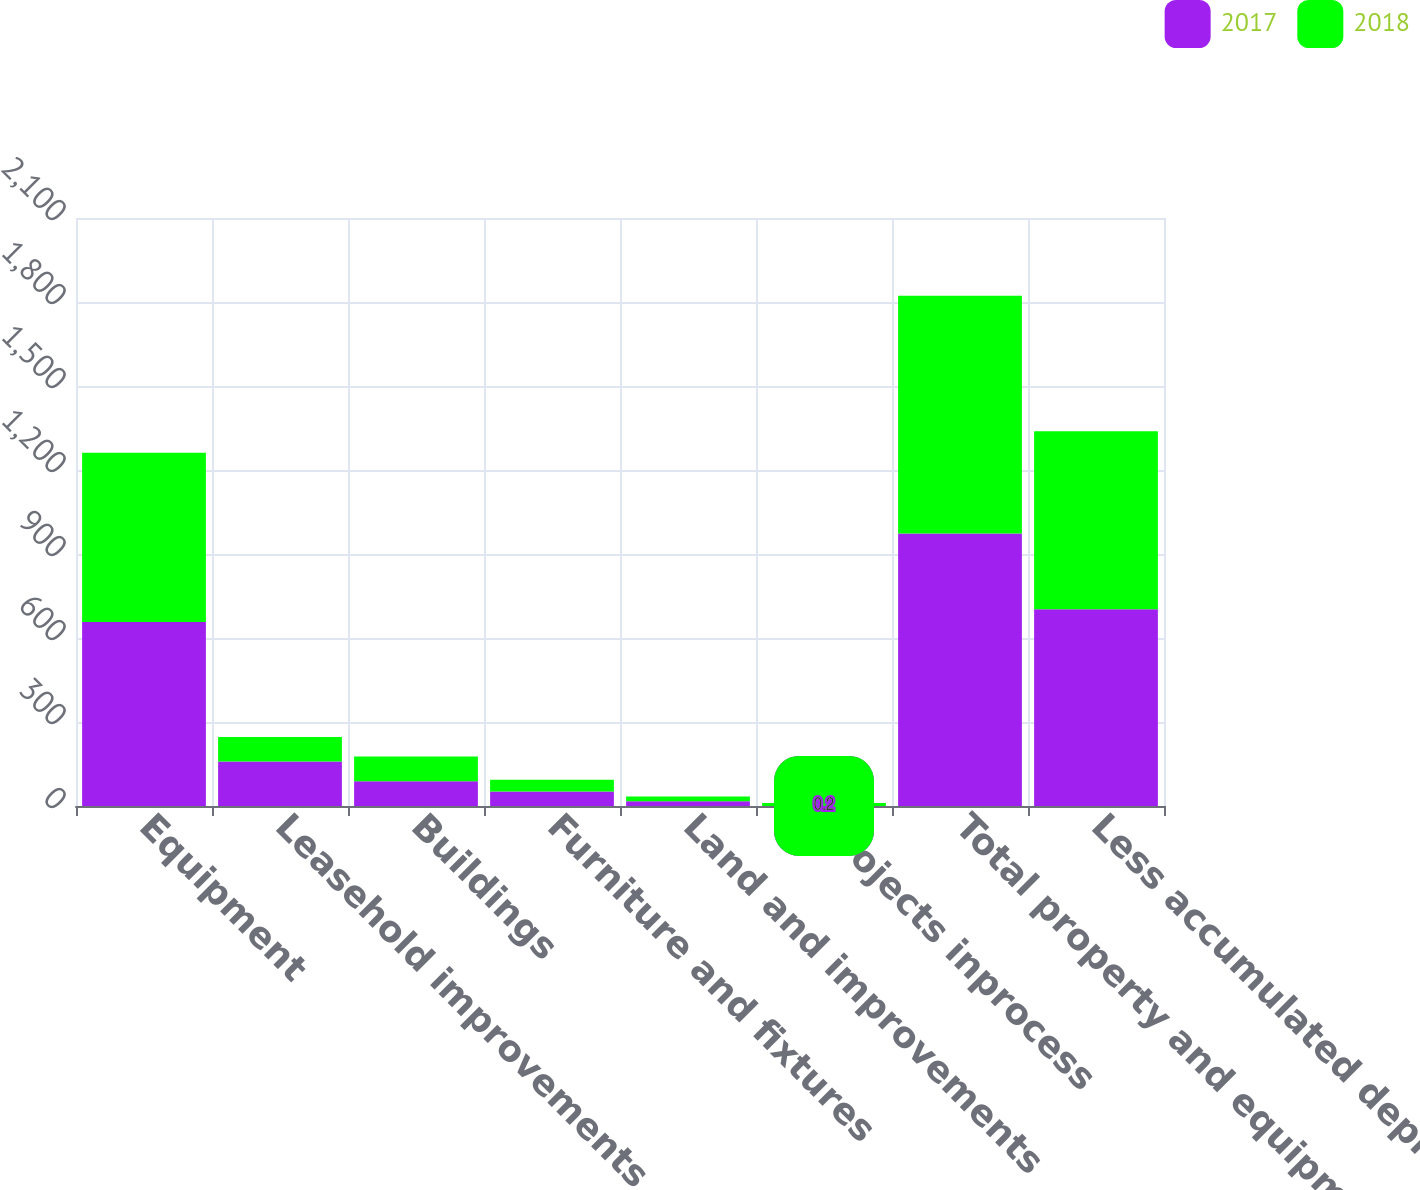Convert chart to OTSL. <chart><loc_0><loc_0><loc_500><loc_500><stacked_bar_chart><ecel><fcel>Equipment<fcel>Leasehold improvements<fcel>Buildings<fcel>Furniture and fixtures<fcel>Land and improvements<fcel>Projects inprocess<fcel>Total property and equipment<fcel>Less accumulated depreciation<nl><fcel>2017<fcel>656.8<fcel>158.6<fcel>88.6<fcel>51.6<fcel>17<fcel>0.2<fcel>972.8<fcel>702.4<nl><fcel>2018<fcel>604.7<fcel>87.4<fcel>88.6<fcel>42<fcel>17<fcel>10.2<fcel>849.9<fcel>635.7<nl></chart> 